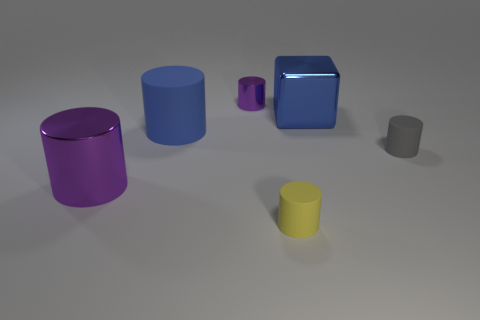Subtract all gray cylinders. How many cylinders are left? 4 Subtract all small shiny cylinders. How many cylinders are left? 4 Subtract all green cylinders. Subtract all yellow spheres. How many cylinders are left? 5 Add 3 big blue blocks. How many objects exist? 9 Subtract all blocks. How many objects are left? 5 Subtract all blue rubber things. Subtract all yellow rubber cylinders. How many objects are left? 4 Add 5 large matte objects. How many large matte objects are left? 6 Add 3 big brown cubes. How many big brown cubes exist? 3 Subtract 0 green cylinders. How many objects are left? 6 